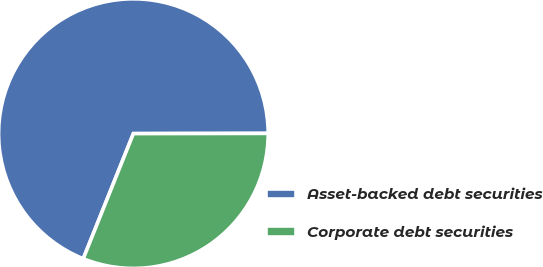Convert chart. <chart><loc_0><loc_0><loc_500><loc_500><pie_chart><fcel>Asset-backed debt securities<fcel>Corporate debt securities<nl><fcel>68.91%<fcel>31.09%<nl></chart> 